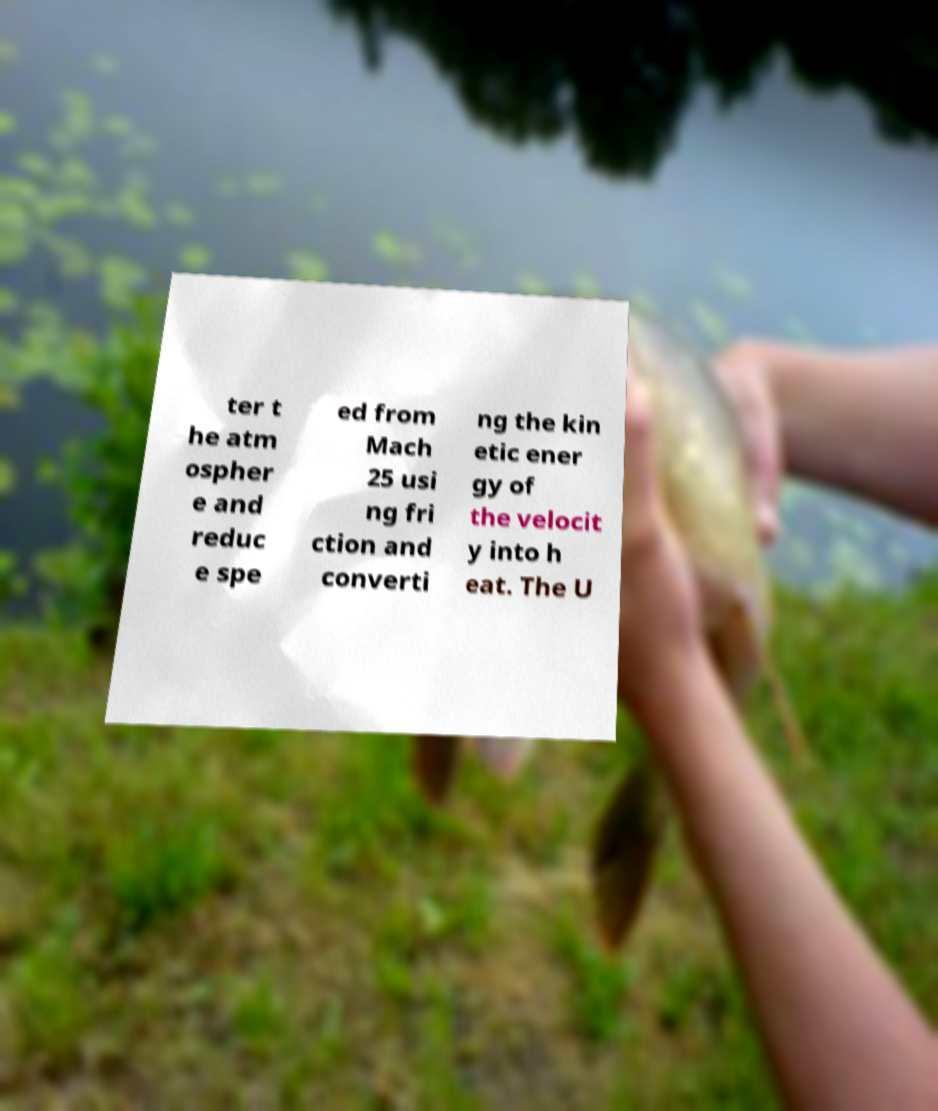Could you assist in decoding the text presented in this image and type it out clearly? ter t he atm ospher e and reduc e spe ed from Mach 25 usi ng fri ction and converti ng the kin etic ener gy of the velocit y into h eat. The U 